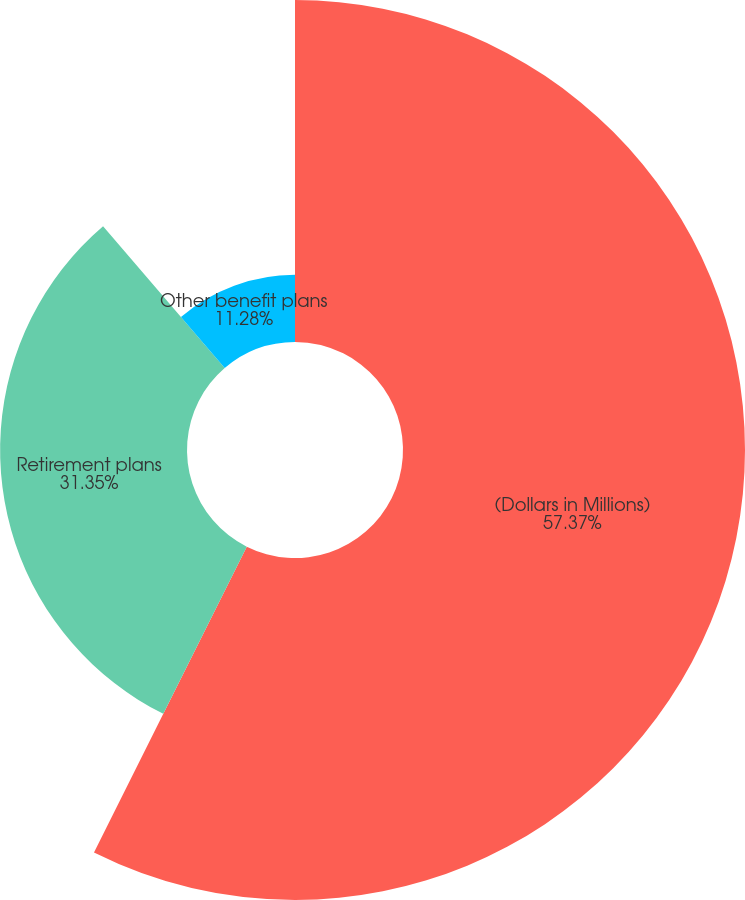Convert chart to OTSL. <chart><loc_0><loc_0><loc_500><loc_500><pie_chart><fcel>(Dollars in Millions)<fcel>Retirement plans<fcel>Other benefit plans<nl><fcel>57.37%<fcel>31.35%<fcel>11.28%<nl></chart> 